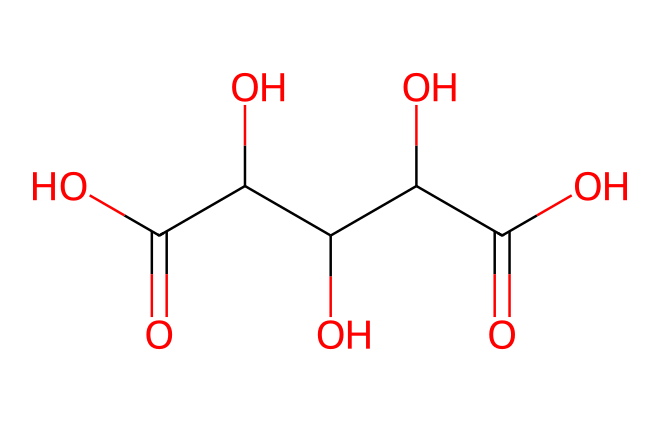What is the molecular formula of the compound represented? To determine the molecular formula, we can count the number of each type of atom present in the SMILES representation. The provided SMILES shows various carbon (C), oxygen (O), and hydrogen (H) atoms. By examining the structure, we can deduce that there are 6 carbons, 10 hydrogens, and 6 oxygens. Thus, the molecular formula is C4H6O6.
Answer: C4H6O6 How many chiral centers are present in this compound? By analyzing the structure derived from the SMILES, we look for carbon atoms that have four different substituents, which indicates a chiral center. In this case, there are two such carbons in the structure. Thus, there are two chiral centers.
Answer: 2 What type of acid is tartaric acid classified as? Tartaric acid is known to have multiple acidic hydrogen atoms, specifically due to the presence of carboxylic acid functional groups (-COOH) in its structure. Given that it contains two -COOH groups, it is classified as a dibasic acid.
Answer: dibasic How many total oxygen atoms are there in the structure? Counting the oxygen atoms from the interpretation of the SMILES structure indicates that there are six oxygen atoms. This can be confirmed by seeing the presence of multiple hydroxyl (-OH) and carboxyl (-COOH) groups within the molecule.
Answer: 6 Which functional groups are present in tartaric acid? The SMILES representation reveals the presence of carboxylic acid groups and hydroxyl groups. Carboxylic functional groups are -COOH and the hydroxyl groups are -OH. Both groups contribute to the acidic properties of this compound.
Answer: carboxylic acid and hydroxyl groups 